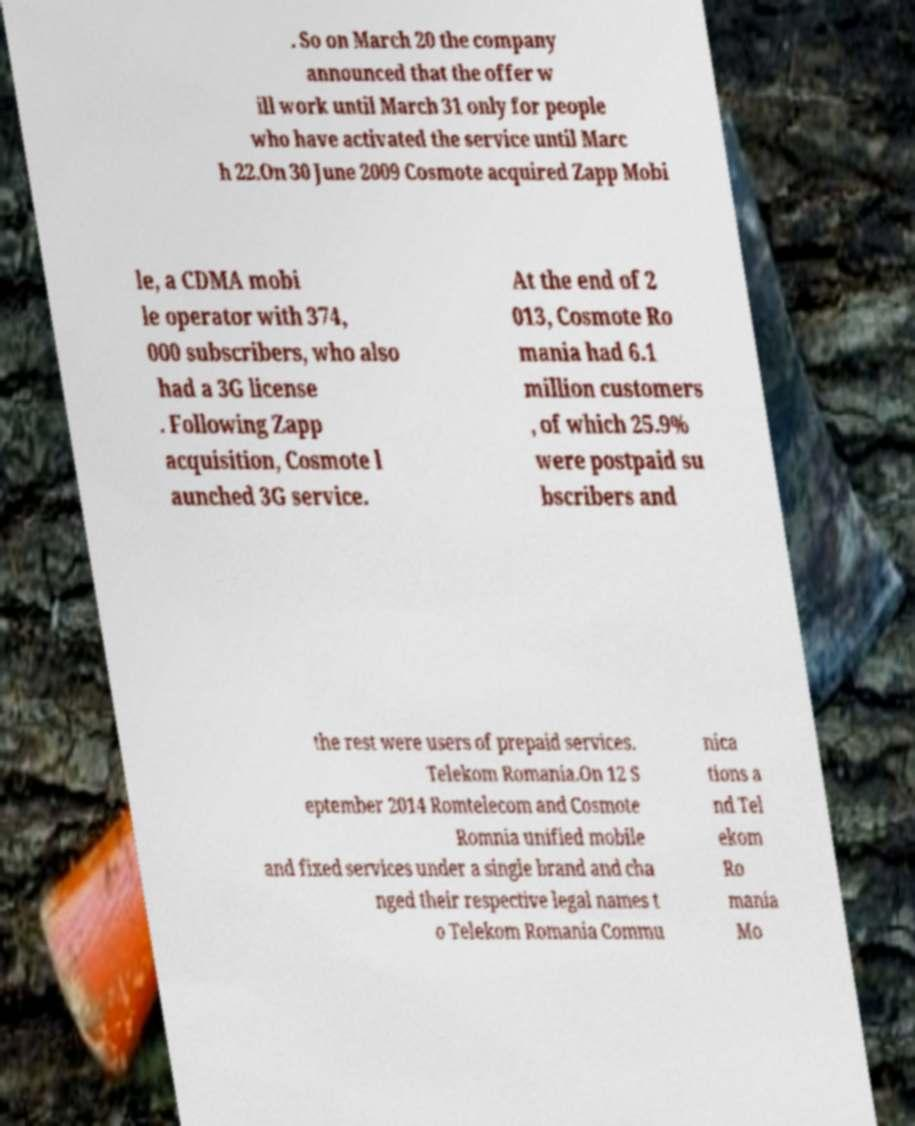Please read and relay the text visible in this image. What does it say? . So on March 20 the company announced that the offer w ill work until March 31 only for people who have activated the service until Marc h 22.On 30 June 2009 Cosmote acquired Zapp Mobi le, a CDMA mobi le operator with 374, 000 subscribers, who also had a 3G license . Following Zapp acquisition, Cosmote l aunched 3G service. At the end of 2 013, Cosmote Ro mania had 6.1 million customers , of which 25.9% were postpaid su bscribers and the rest were users of prepaid services. Telekom Romania.On 12 S eptember 2014 Romtelecom and Cosmote Romnia unified mobile and fixed services under a single brand and cha nged their respective legal names t o Telekom Romania Commu nica tions a nd Tel ekom Ro mania Mo 